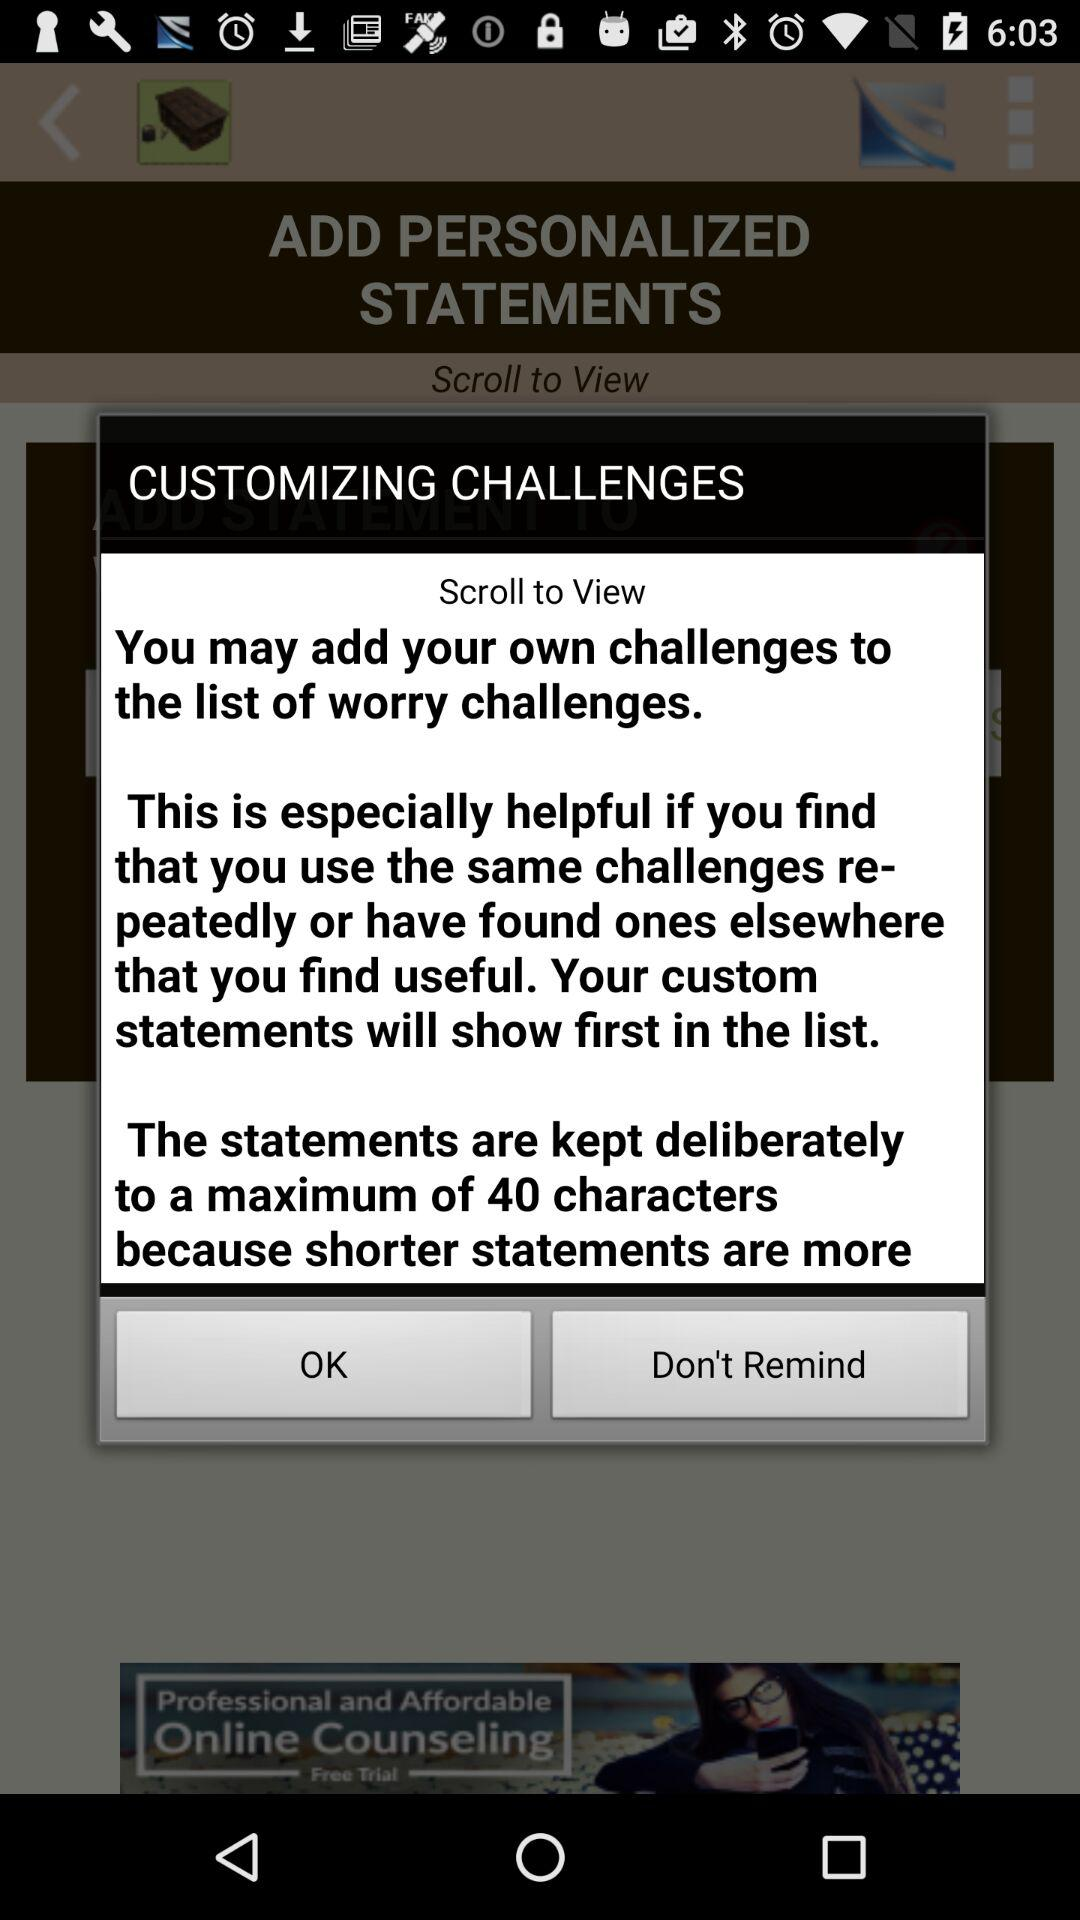What is the maximum number of characters for the statements? The maximum number of characters for the statements is 40. 